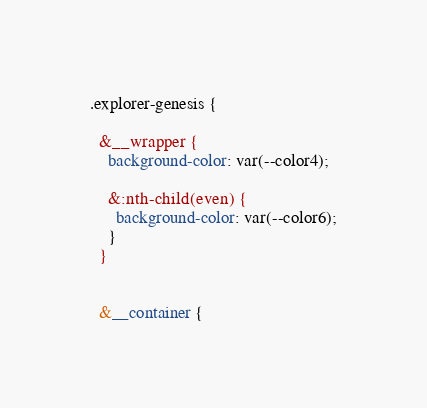<code> <loc_0><loc_0><loc_500><loc_500><_CSS_>
.explorer-genesis {

  &__wrapper {
    background-color: var(--color4);

    &:nth-child(even) {
      background-color: var(--color6);
    }
  }


  &__container {</code> 